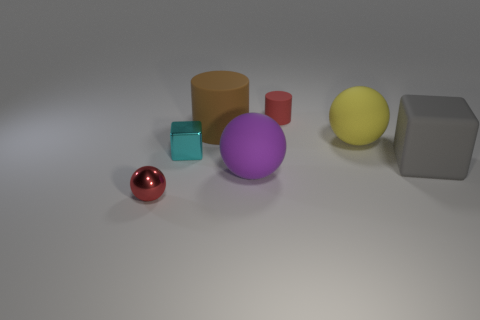Add 1 big brown rubber spheres. How many objects exist? 8 Subtract all cylinders. How many objects are left? 5 Subtract all tiny matte objects. Subtract all big gray rubber blocks. How many objects are left? 5 Add 2 big yellow things. How many big yellow things are left? 3 Add 4 tiny cylinders. How many tiny cylinders exist? 5 Subtract 0 brown blocks. How many objects are left? 7 